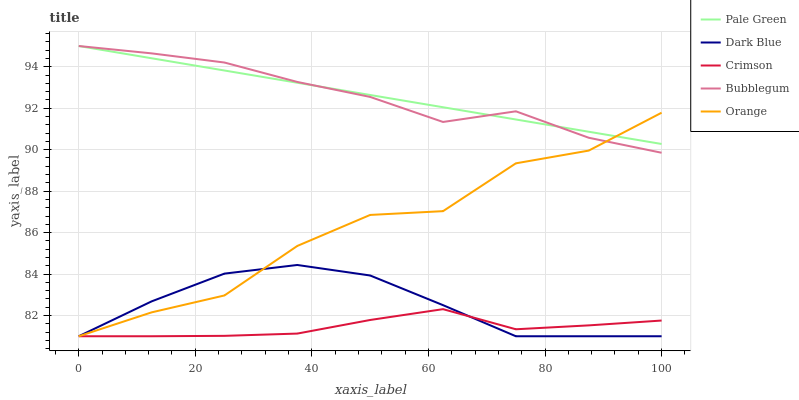Does Crimson have the minimum area under the curve?
Answer yes or no. Yes. Does Pale Green have the maximum area under the curve?
Answer yes or no. Yes. Does Dark Blue have the minimum area under the curve?
Answer yes or no. No. Does Dark Blue have the maximum area under the curve?
Answer yes or no. No. Is Pale Green the smoothest?
Answer yes or no. Yes. Is Orange the roughest?
Answer yes or no. Yes. Is Dark Blue the smoothest?
Answer yes or no. No. Is Dark Blue the roughest?
Answer yes or no. No. Does Crimson have the lowest value?
Answer yes or no. Yes. Does Pale Green have the lowest value?
Answer yes or no. No. Does Bubblegum have the highest value?
Answer yes or no. Yes. Does Dark Blue have the highest value?
Answer yes or no. No. Is Dark Blue less than Bubblegum?
Answer yes or no. Yes. Is Pale Green greater than Dark Blue?
Answer yes or no. Yes. Does Pale Green intersect Orange?
Answer yes or no. Yes. Is Pale Green less than Orange?
Answer yes or no. No. Is Pale Green greater than Orange?
Answer yes or no. No. Does Dark Blue intersect Bubblegum?
Answer yes or no. No. 